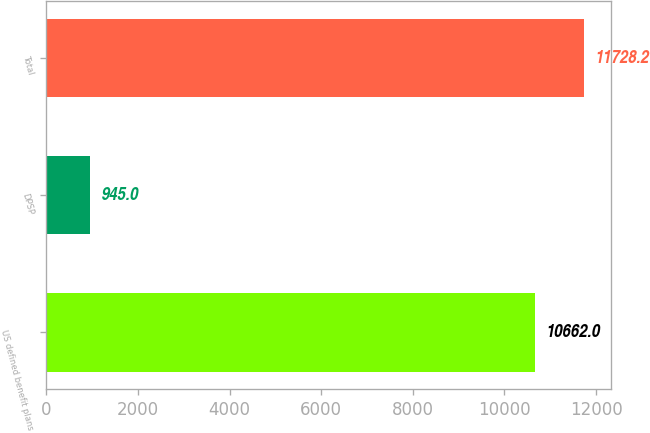Convert chart. <chart><loc_0><loc_0><loc_500><loc_500><bar_chart><fcel>US defined benefit plans<fcel>DPSP<fcel>Total<nl><fcel>10662<fcel>945<fcel>11728.2<nl></chart> 